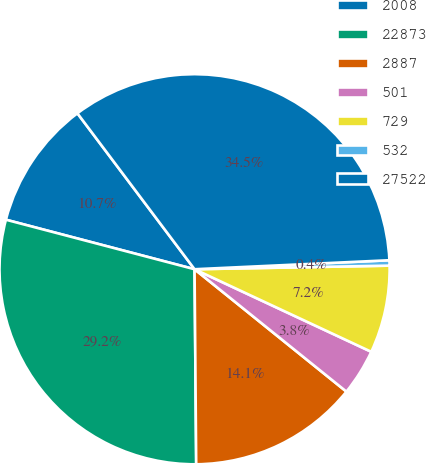Convert chart to OTSL. <chart><loc_0><loc_0><loc_500><loc_500><pie_chart><fcel>2008<fcel>22873<fcel>2887<fcel>501<fcel>729<fcel>532<fcel>27522<nl><fcel>10.66%<fcel>29.22%<fcel>14.07%<fcel>3.84%<fcel>7.25%<fcel>0.44%<fcel>34.52%<nl></chart> 